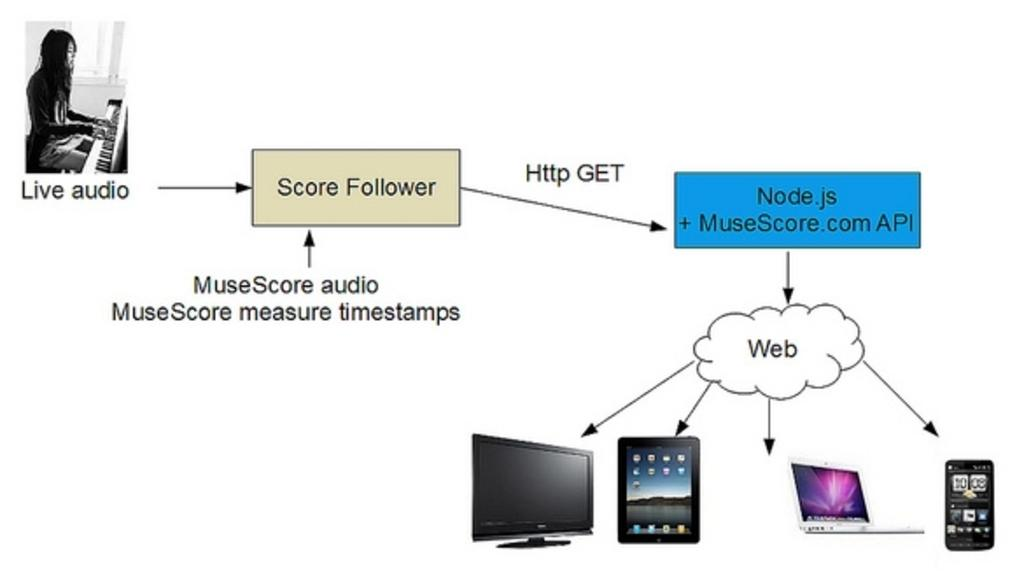<image>
Describe the image concisely. A diagram provides information about how the MuseScore music program works. 